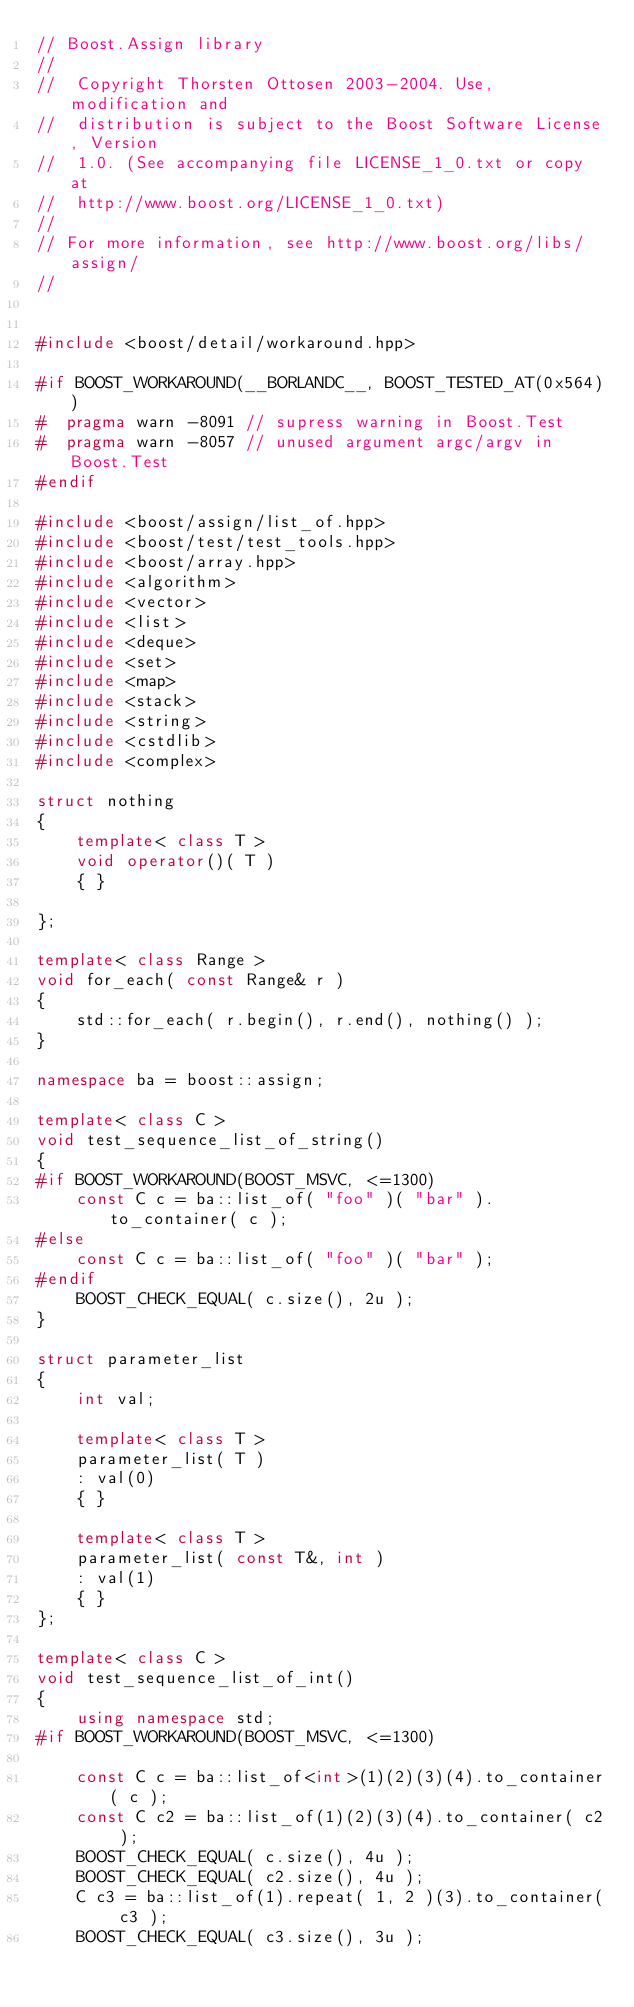<code> <loc_0><loc_0><loc_500><loc_500><_C++_>// Boost.Assign library
//
//  Copyright Thorsten Ottosen 2003-2004. Use, modification and
//  distribution is subject to the Boost Software License, Version
//  1.0. (See accompanying file LICENSE_1_0.txt or copy at
//  http://www.boost.org/LICENSE_1_0.txt)
//
// For more information, see http://www.boost.org/libs/assign/
//


#include <boost/detail/workaround.hpp>

#if BOOST_WORKAROUND(__BORLANDC__, BOOST_TESTED_AT(0x564))
#  pragma warn -8091 // supress warning in Boost.Test
#  pragma warn -8057 // unused argument argc/argv in Boost.Test
#endif

#include <boost/assign/list_of.hpp>
#include <boost/test/test_tools.hpp>
#include <boost/array.hpp>
#include <algorithm>
#include <vector>
#include <list>
#include <deque>
#include <set>
#include <map>
#include <stack>
#include <string>
#include <cstdlib>
#include <complex>

struct nothing
{
    template< class T >
    void operator()( T )
    { }
    
};

template< class Range >
void for_each( const Range& r )
{
    std::for_each( r.begin(), r.end(), nothing() );
}

namespace ba = boost::assign;
    
template< class C >
void test_sequence_list_of_string()
{
#if BOOST_WORKAROUND(BOOST_MSVC, <=1300)
    const C c = ba::list_of( "foo" )( "bar" ).to_container( c );   
#else
    const C c = ba::list_of( "foo" )( "bar" );   
#endif
    BOOST_CHECK_EQUAL( c.size(), 2u );
}

struct parameter_list
{
    int val;
    
    template< class T >
    parameter_list( T )
    : val(0)
    { }
    
    template< class T >
    parameter_list( const T&, int )
    : val(1)
    { }
};

template< class C >
void test_sequence_list_of_int()
{
    using namespace std;
#if BOOST_WORKAROUND(BOOST_MSVC, <=1300)

    const C c = ba::list_of<int>(1)(2)(3)(4).to_container( c );
    const C c2 = ba::list_of(1)(2)(3)(4).to_container( c2 );
    BOOST_CHECK_EQUAL( c.size(), 4u );
    BOOST_CHECK_EQUAL( c2.size(), 4u );
    C c3 = ba::list_of(1).repeat( 1, 2 )(3).to_container( c3 );
    BOOST_CHECK_EQUAL( c3.size(), 3u );
        </code> 